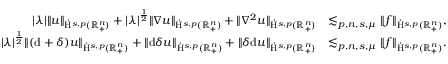Convert formula to latex. <formula><loc_0><loc_0><loc_500><loc_500>\begin{array} { r l } { | \lambda | \| u \| _ { \dot { H } ^ { s , p } ( \mathbb { R } _ { + } ^ { n } ) } + | \lambda | ^ { \frac { 1 } { 2 } } \| \nabla u \| _ { \dot { H } ^ { s , p } ( \mathbb { R } _ { + } ^ { n } ) } + \| \nabla ^ { 2 } u \| _ { \dot { H } ^ { s , p } ( \mathbb { R } _ { + } ^ { n } ) } } & { \lesssim _ { p , n , s , \mu } \| f \| _ { \dot { H } ^ { s , p } ( \mathbb { R } _ { + } ^ { n } ) } , } \\ { | \lambda | ^ { \frac { 1 } { 2 } } \| ( d + \delta ) u \| _ { \dot { H } ^ { s , p } ( \mathbb { R } _ { + } ^ { n } ) } + \| d \delta u \| _ { \dot { H } ^ { s , p } ( \mathbb { R } _ { + } ^ { n } ) } + \| \delta d u \| _ { \dot { H } ^ { s , p } ( \mathbb { R } _ { + } ^ { n } ) } } & { \lesssim _ { p , n , s , \mu } \| f \| _ { \dot { H } ^ { s , p } ( \mathbb { R } _ { + } ^ { n } ) } . } \end{array}</formula> 